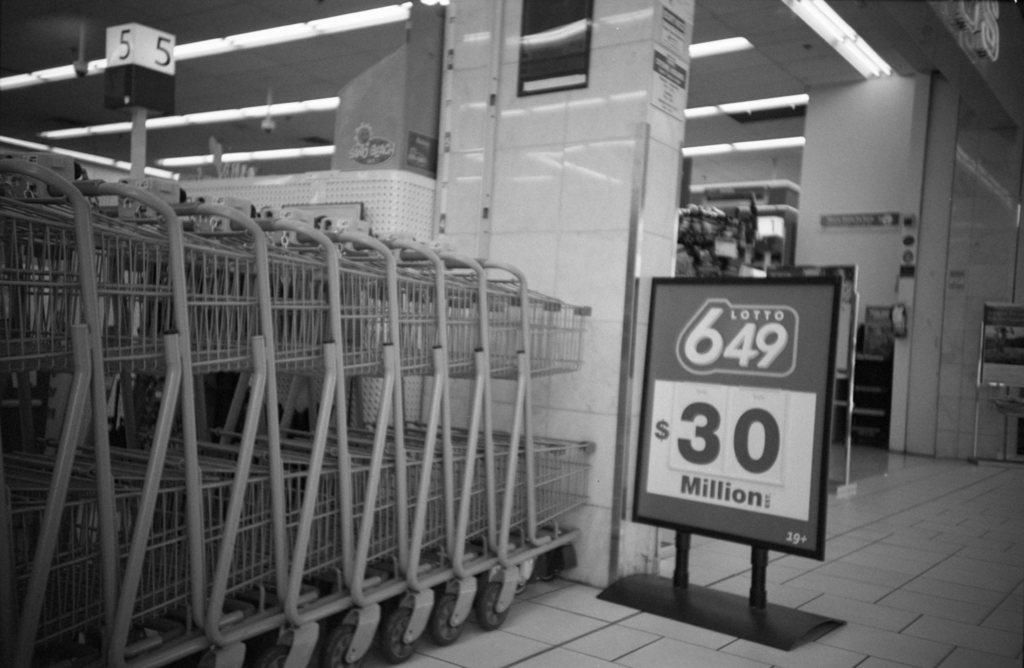<image>
Create a compact narrative representing the image presented. A signboard for Lotto 649 advertising that the lottery is worth $30 million. 